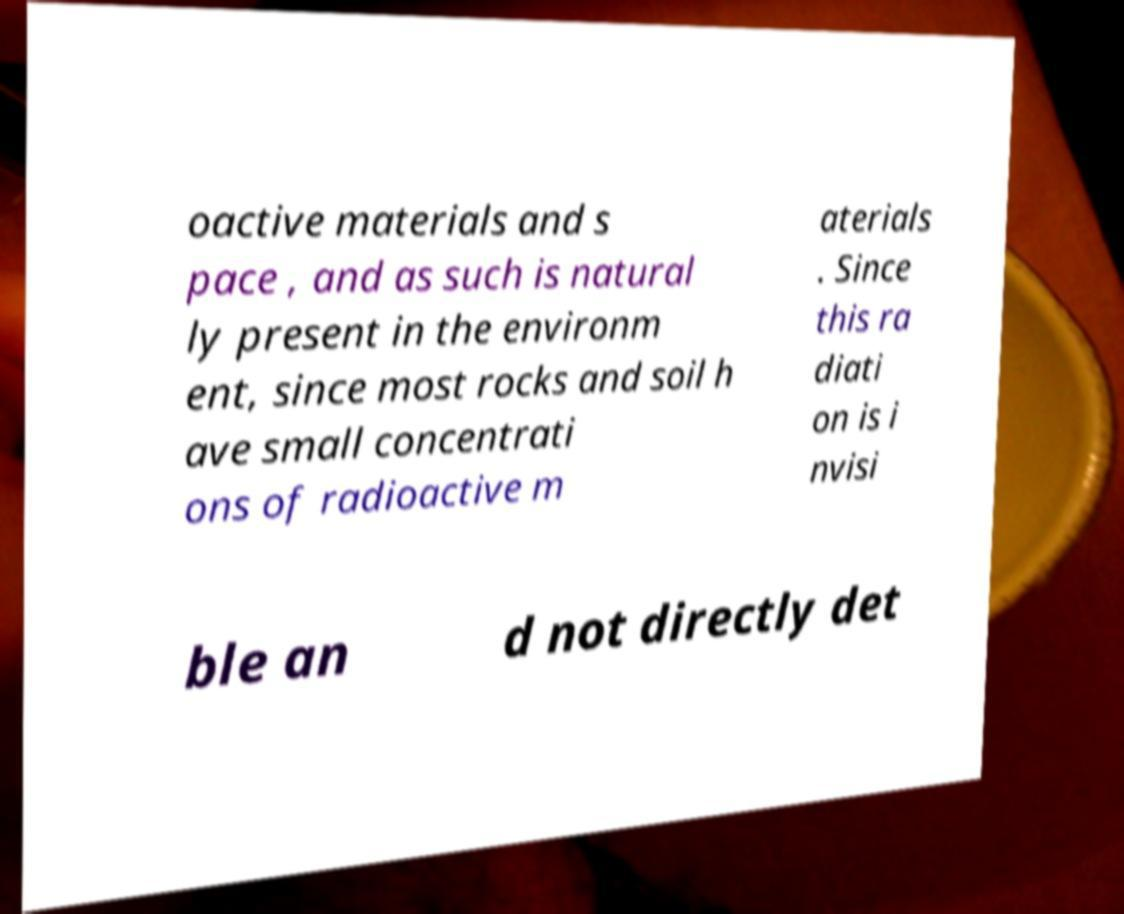For documentation purposes, I need the text within this image transcribed. Could you provide that? oactive materials and s pace , and as such is natural ly present in the environm ent, since most rocks and soil h ave small concentrati ons of radioactive m aterials . Since this ra diati on is i nvisi ble an d not directly det 